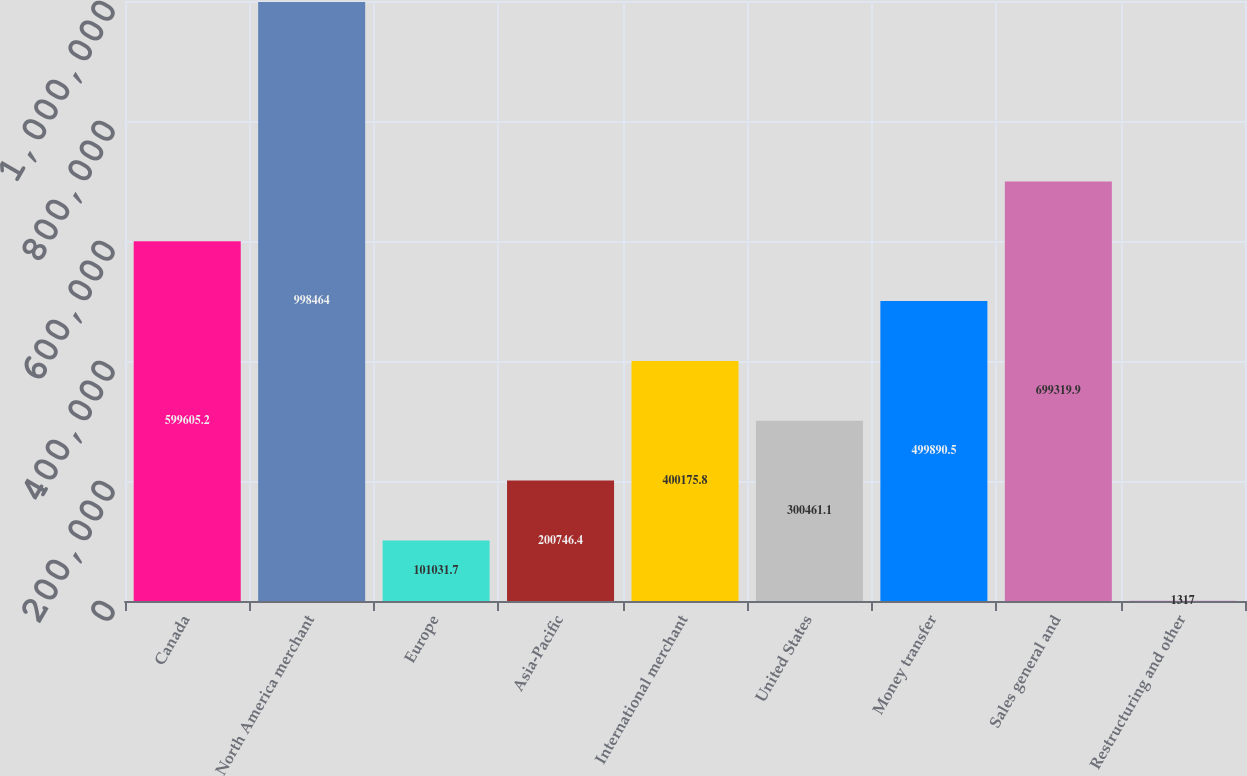<chart> <loc_0><loc_0><loc_500><loc_500><bar_chart><fcel>Canada<fcel>North America merchant<fcel>Europe<fcel>Asia-Pacific<fcel>International merchant<fcel>United States<fcel>Money transfer<fcel>Sales general and<fcel>Restructuring and other<nl><fcel>599605<fcel>998464<fcel>101032<fcel>200746<fcel>400176<fcel>300461<fcel>499890<fcel>699320<fcel>1317<nl></chart> 